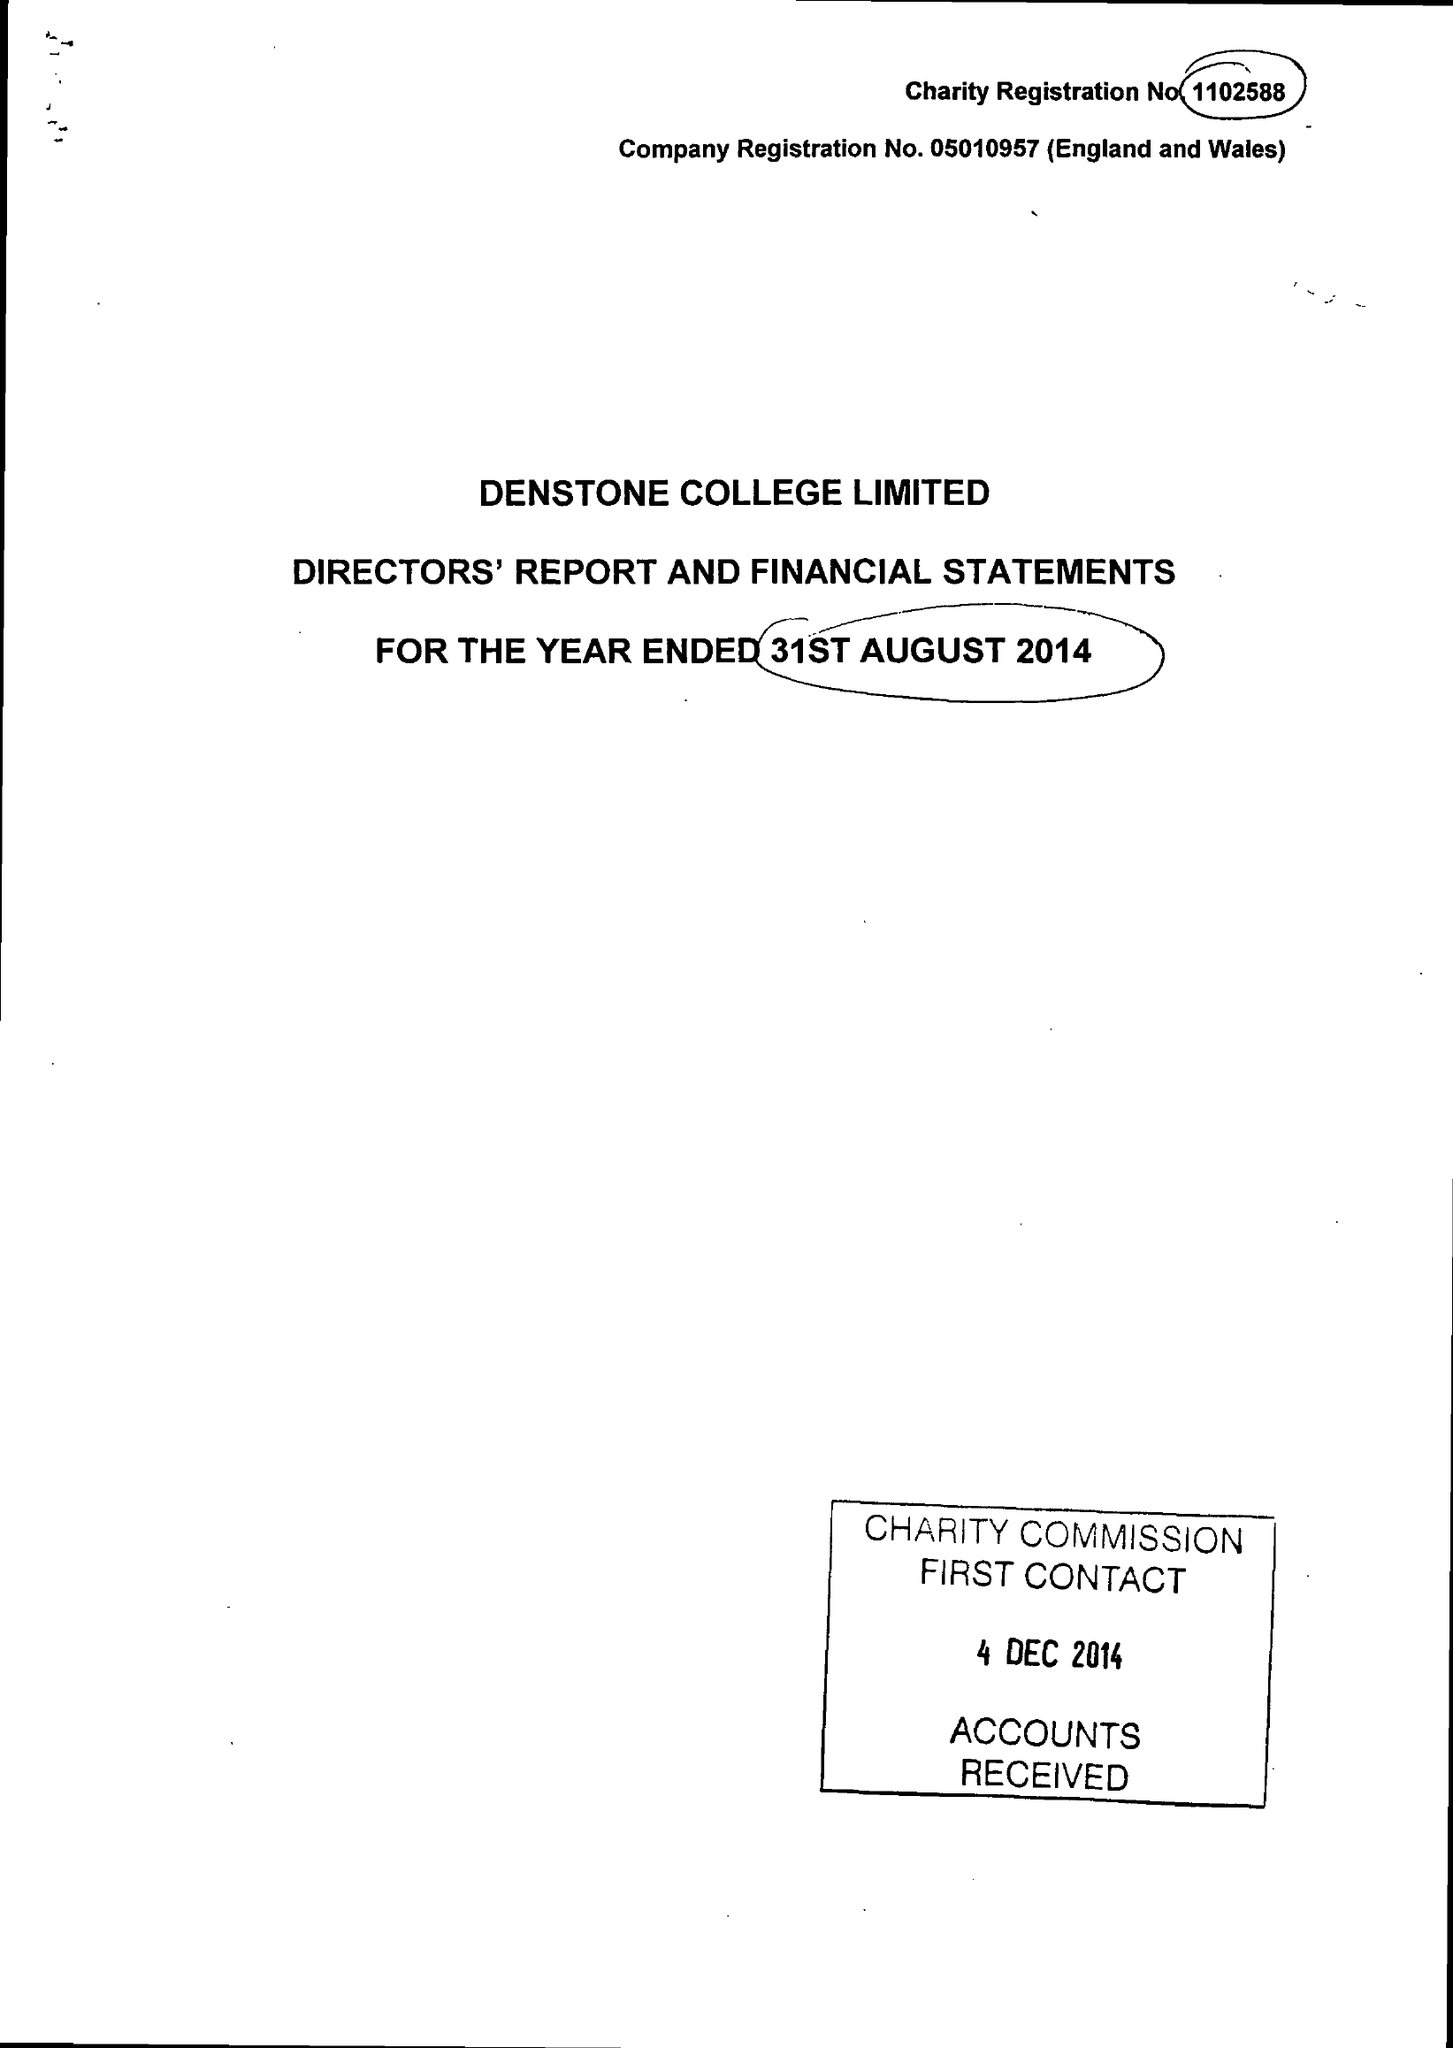What is the value for the report_date?
Answer the question using a single word or phrase. 2014-08-31 